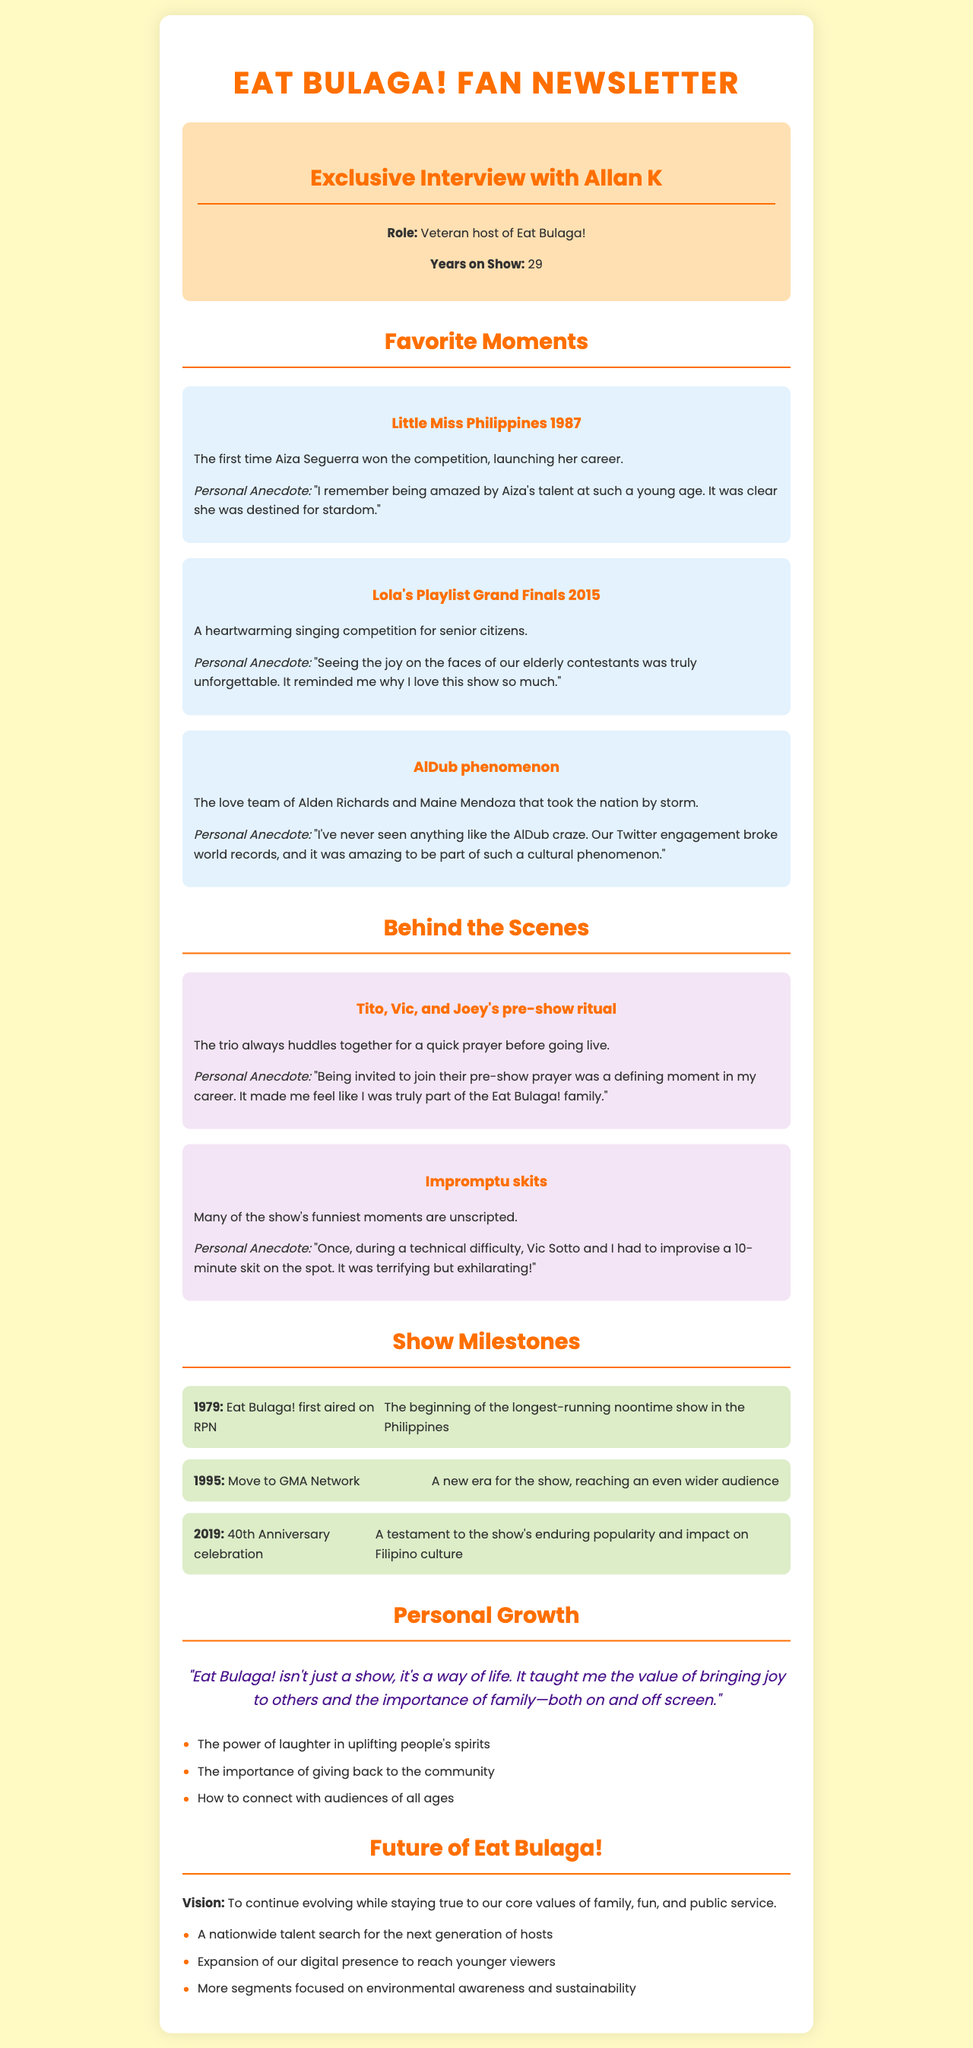What is the name of the veteran host interviewed? The document introduces the veteran host as Allan K, who has been a long-time host of the show.
Answer: Allan K How many years has Allan K been on the show? According to the document, Allan K has been a host of Eat Bulaga! for 29 years.
Answer: 29 What significant event occurred in 1995 for Eat Bulaga!? The document notes that in 1995, Eat Bulaga! moved to GMA Network, marking a new era for the show.
Answer: Move to GMA Network What was Aiza Seguerra recognized for in 1987? The document states that Aiza Seguerra won the Little Miss Philippines competition in 1987, launching her career.
Answer: Little Miss Philippines 1987 What is a key lesson learned from being part of Eat Bulaga!? Allan K reflects on the importance of laughter and its uplifting effects, which is one lesson from his experience.
Answer: The power of laughter in uplifting people's spirits What was a defining moment for Allan K in his career? Allan K describes being invited to join Tito, Vic, and Joey's pre-show prayer as a significant moment that made him feel part of the family.
Answer: Pre-show prayer invitation What is one of the upcoming projects mentioned for Eat Bulaga!? The document lists a nationwide talent search as one of the future projects for the show.
Answer: Nationwide talent search What aspect of Eat Bulaga! does Allan K emphasize in his vision for the show? Allan K mentions that the core values of family, fun, and public service must be maintained as the show continues to evolve.
Answer: Core values of family, fun, and public service 